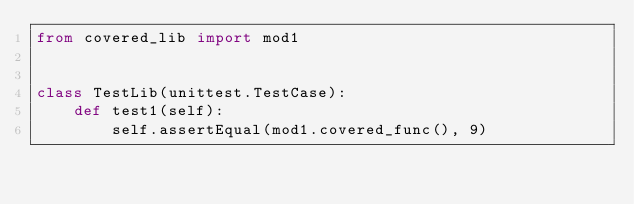<code> <loc_0><loc_0><loc_500><loc_500><_Python_>from covered_lib import mod1


class TestLib(unittest.TestCase):
    def test1(self):
        self.assertEqual(mod1.covered_func(), 9)
</code> 